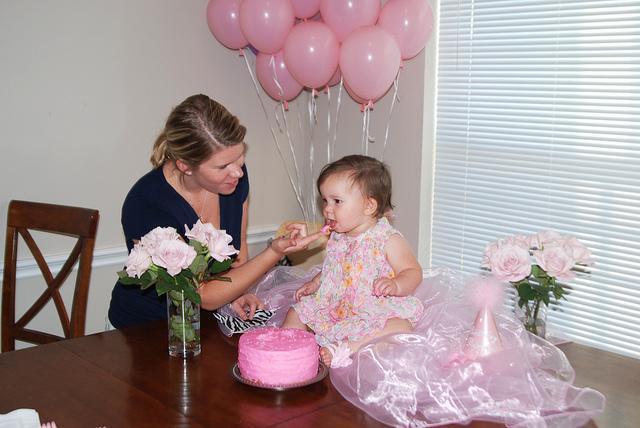How many people can be seen?
Give a very brief answer. 2. 